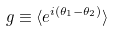<formula> <loc_0><loc_0><loc_500><loc_500>g \equiv \langle e ^ { i ( \theta _ { 1 } - \theta _ { 2 } ) } \rangle</formula> 